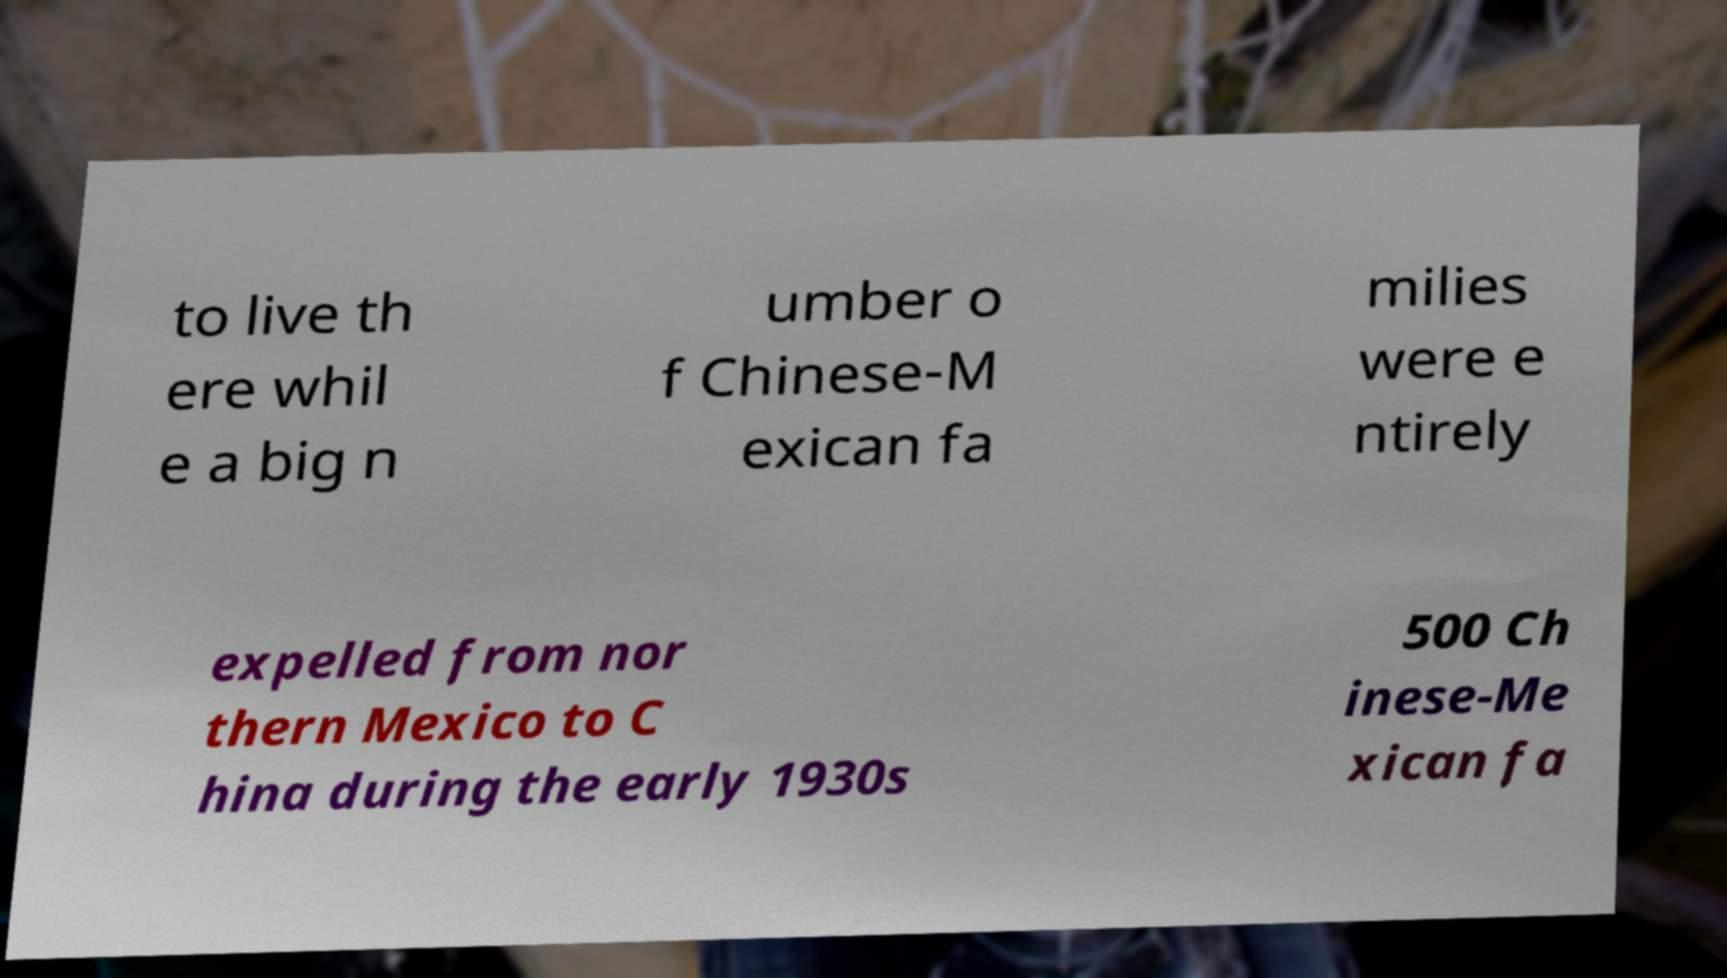I need the written content from this picture converted into text. Can you do that? to live th ere whil e a big n umber o f Chinese-M exican fa milies were e ntirely expelled from nor thern Mexico to C hina during the early 1930s 500 Ch inese-Me xican fa 